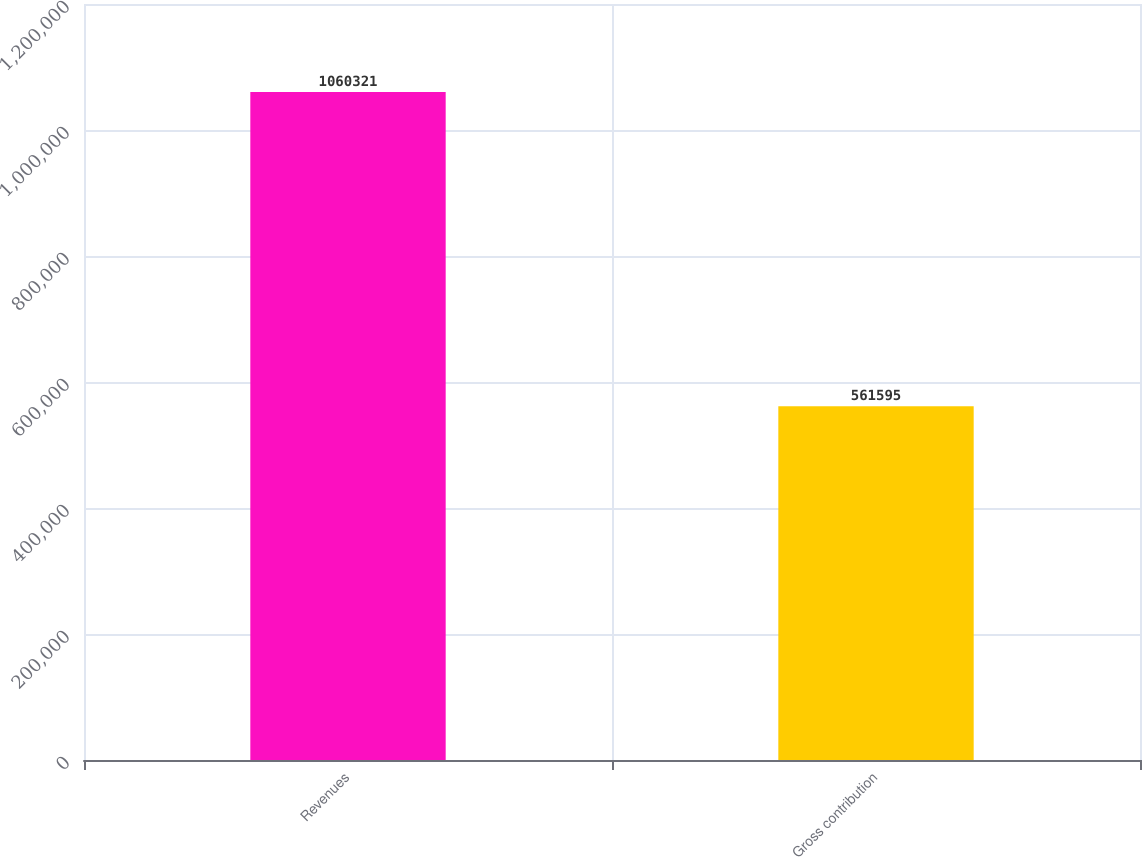Convert chart. <chart><loc_0><loc_0><loc_500><loc_500><bar_chart><fcel>Revenues<fcel>Gross contribution<nl><fcel>1.06032e+06<fcel>561595<nl></chart> 